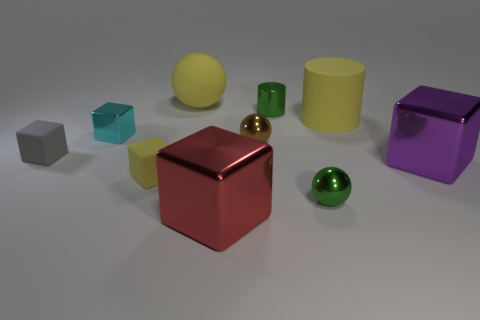How many other objects are the same color as the large ball?
Ensure brevity in your answer.  2. How many red objects are either rubber spheres or small metal cylinders?
Ensure brevity in your answer.  0. There is a cyan thing; is its shape the same as the tiny green metal thing that is behind the tiny gray object?
Your response must be concise. No. What is the shape of the brown metallic thing?
Offer a terse response. Sphere. There is a cube that is the same size as the purple metal thing; what material is it?
Give a very brief answer. Metal. Are there any other things that are the same size as the red cube?
Provide a short and direct response. Yes. How many things are either tiny green things or shiny balls in front of the big purple object?
Offer a very short reply. 2. The cyan block that is the same material as the tiny green sphere is what size?
Make the answer very short. Small. What is the shape of the tiny shiny object in front of the small cube in front of the large purple object?
Your response must be concise. Sphere. What size is the sphere that is on the left side of the metal cylinder and to the right of the big rubber ball?
Keep it short and to the point. Small. 